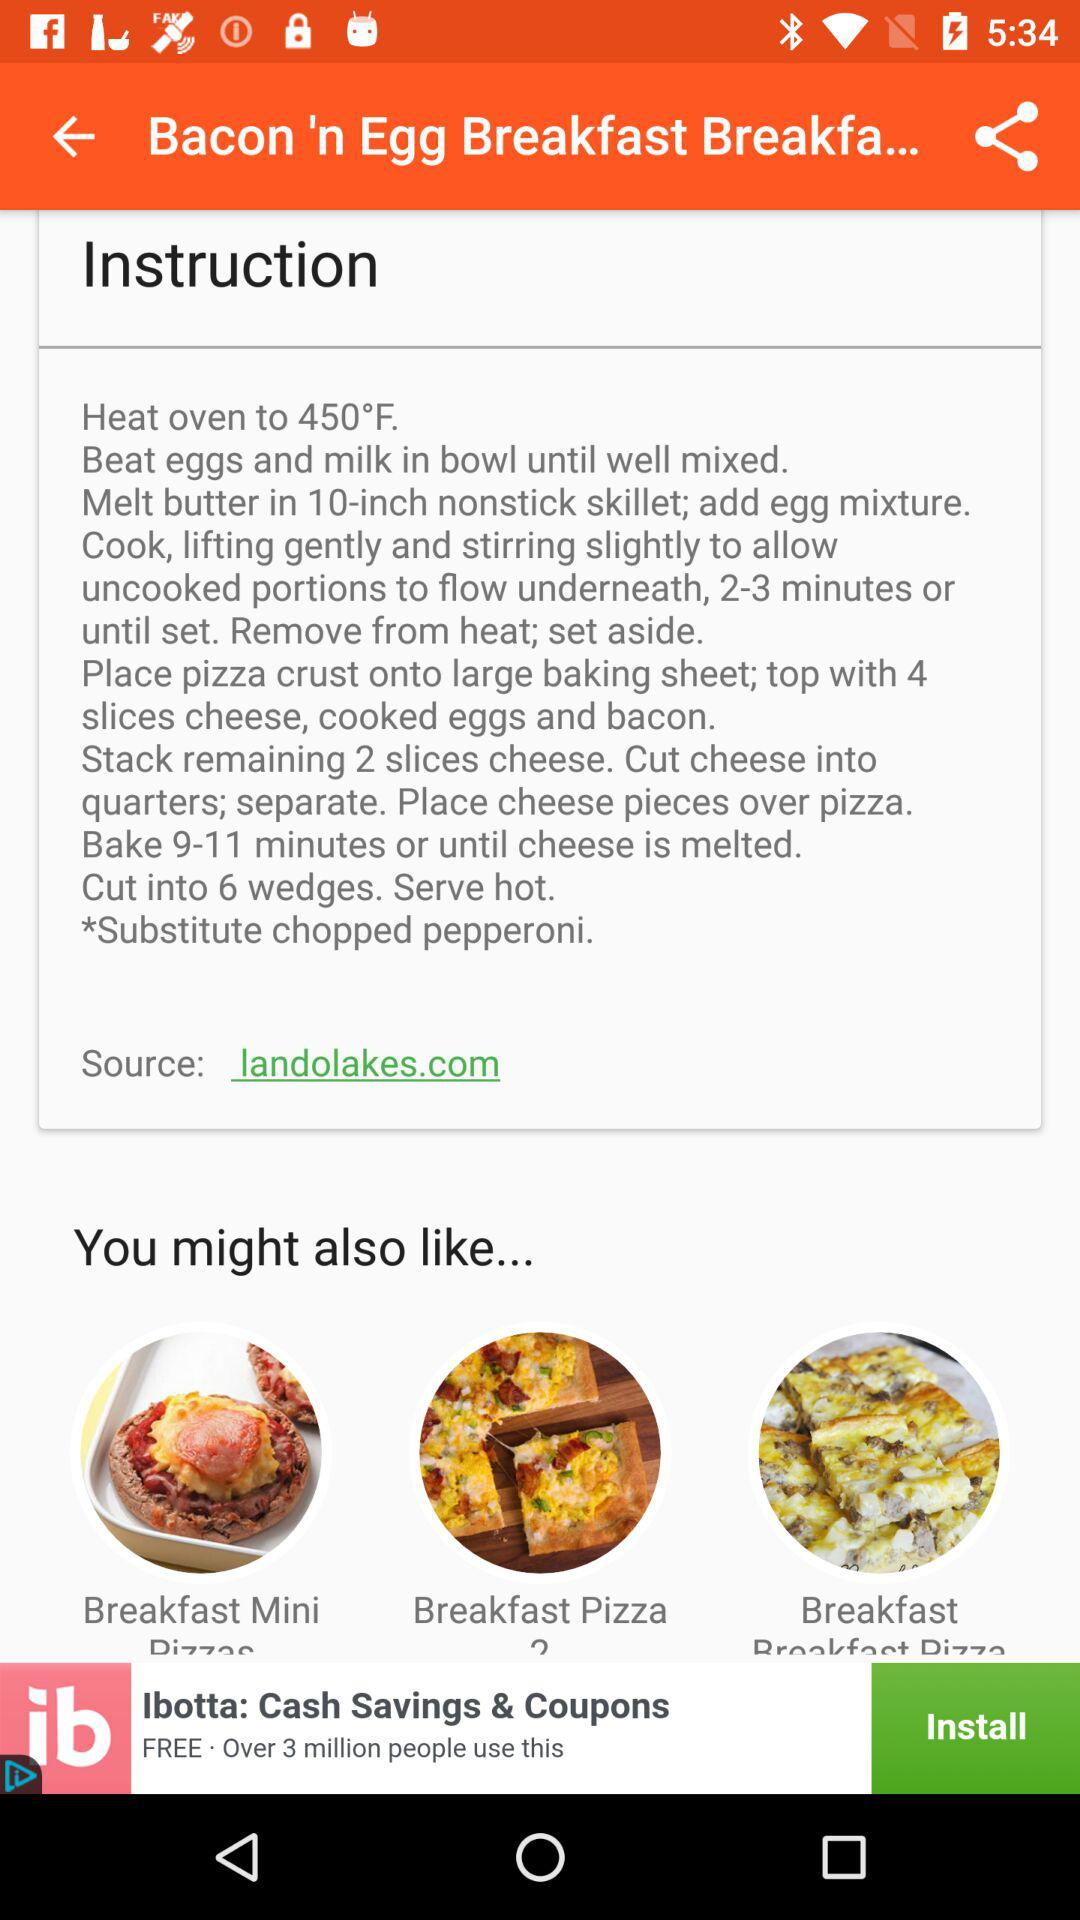What is the heat oven temperature? The heat oven temperature is 450°F. 